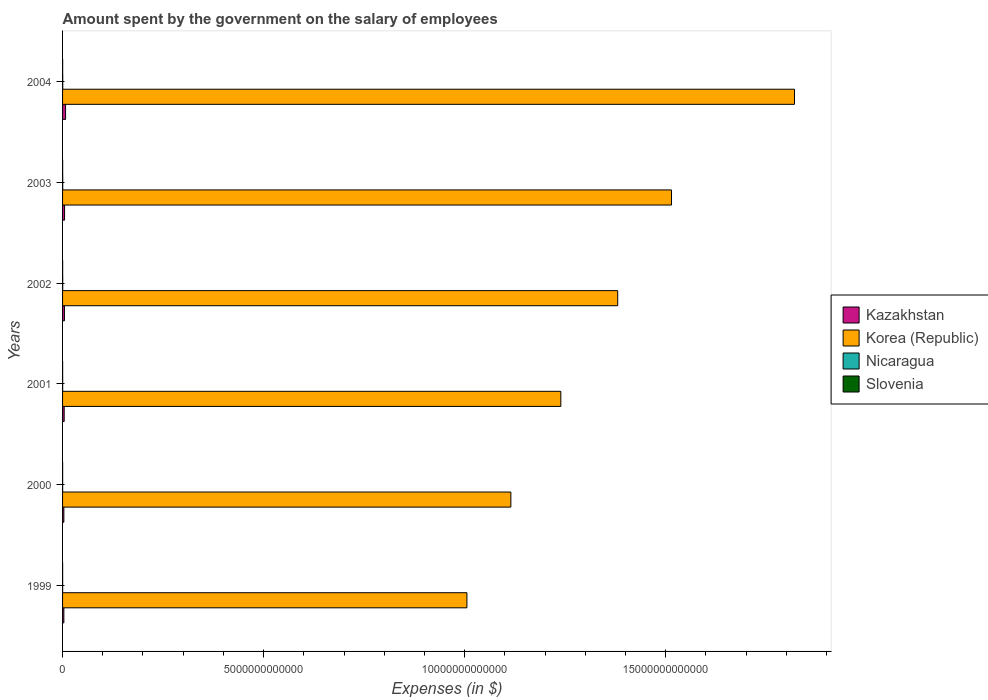How many different coloured bars are there?
Provide a succinct answer. 4. How many groups of bars are there?
Offer a very short reply. 6. Are the number of bars per tick equal to the number of legend labels?
Offer a very short reply. Yes. What is the label of the 1st group of bars from the top?
Offer a terse response. 2004. In how many cases, is the number of bars for a given year not equal to the number of legend labels?
Offer a terse response. 0. What is the amount spent on the salary of employees by the government in Nicaragua in 2001?
Your answer should be very brief. 2.25e+09. Across all years, what is the maximum amount spent on the salary of employees by the government in Slovenia?
Ensure brevity in your answer.  2.02e+09. Across all years, what is the minimum amount spent on the salary of employees by the government in Nicaragua?
Ensure brevity in your answer.  1.68e+09. In which year was the amount spent on the salary of employees by the government in Korea (Republic) minimum?
Offer a very short reply. 1999. What is the total amount spent on the salary of employees by the government in Kazakhstan in the graph?
Give a very brief answer. 2.76e+11. What is the difference between the amount spent on the salary of employees by the government in Nicaragua in 2000 and that in 2002?
Your answer should be compact. -1.56e+09. What is the difference between the amount spent on the salary of employees by the government in Nicaragua in 2000 and the amount spent on the salary of employees by the government in Kazakhstan in 1999?
Your answer should be very brief. -3.05e+1. What is the average amount spent on the salary of employees by the government in Korea (Republic) per year?
Offer a terse response. 1.35e+13. In the year 2003, what is the difference between the amount spent on the salary of employees by the government in Korea (Republic) and amount spent on the salary of employees by the government in Nicaragua?
Provide a succinct answer. 1.51e+13. In how many years, is the amount spent on the salary of employees by the government in Korea (Republic) greater than 7000000000000 $?
Your answer should be very brief. 6. What is the ratio of the amount spent on the salary of employees by the government in Korea (Republic) in 2003 to that in 2004?
Offer a terse response. 0.83. Is the amount spent on the salary of employees by the government in Kazakhstan in 1999 less than that in 2001?
Provide a short and direct response. Yes. What is the difference between the highest and the second highest amount spent on the salary of employees by the government in Kazakhstan?
Keep it short and to the point. 2.48e+1. What is the difference between the highest and the lowest amount spent on the salary of employees by the government in Korea (Republic)?
Keep it short and to the point. 8.15e+12. In how many years, is the amount spent on the salary of employees by the government in Kazakhstan greater than the average amount spent on the salary of employees by the government in Kazakhstan taken over all years?
Offer a very short reply. 3. What does the 2nd bar from the top in 2001 represents?
Make the answer very short. Nicaragua. What does the 3rd bar from the bottom in 2001 represents?
Keep it short and to the point. Nicaragua. Is it the case that in every year, the sum of the amount spent on the salary of employees by the government in Slovenia and amount spent on the salary of employees by the government in Korea (Republic) is greater than the amount spent on the salary of employees by the government in Kazakhstan?
Your answer should be compact. Yes. How many bars are there?
Your answer should be very brief. 24. What is the difference between two consecutive major ticks on the X-axis?
Your answer should be compact. 5.00e+12. Are the values on the major ticks of X-axis written in scientific E-notation?
Ensure brevity in your answer.  No. Does the graph contain grids?
Your answer should be very brief. No. Where does the legend appear in the graph?
Provide a short and direct response. Center right. What is the title of the graph?
Ensure brevity in your answer.  Amount spent by the government on the salary of employees. What is the label or title of the X-axis?
Your answer should be very brief. Expenses (in $). What is the label or title of the Y-axis?
Offer a terse response. Years. What is the Expenses (in $) of Kazakhstan in 1999?
Give a very brief answer. 3.23e+1. What is the Expenses (in $) in Korea (Republic) in 1999?
Your answer should be very brief. 1.01e+13. What is the Expenses (in $) in Nicaragua in 1999?
Your answer should be compact. 1.68e+09. What is the Expenses (in $) of Slovenia in 1999?
Offer a very short reply. 1.34e+09. What is the Expenses (in $) of Kazakhstan in 2000?
Keep it short and to the point. 3.23e+1. What is the Expenses (in $) of Korea (Republic) in 2000?
Provide a short and direct response. 1.12e+13. What is the Expenses (in $) of Nicaragua in 2000?
Make the answer very short. 1.89e+09. What is the Expenses (in $) of Slovenia in 2000?
Ensure brevity in your answer.  1.30e+09. What is the Expenses (in $) in Kazakhstan in 2001?
Your answer should be very brief. 4.00e+1. What is the Expenses (in $) of Korea (Republic) in 2001?
Give a very brief answer. 1.24e+13. What is the Expenses (in $) in Nicaragua in 2001?
Your response must be concise. 2.25e+09. What is the Expenses (in $) in Slovenia in 2001?
Your answer should be very brief. 1.55e+09. What is the Expenses (in $) in Kazakhstan in 2002?
Your answer should be very brief. 4.66e+1. What is the Expenses (in $) in Korea (Republic) in 2002?
Keep it short and to the point. 1.38e+13. What is the Expenses (in $) of Nicaragua in 2002?
Your answer should be very brief. 3.44e+09. What is the Expenses (in $) of Slovenia in 2002?
Your response must be concise. 1.67e+09. What is the Expenses (in $) in Kazakhstan in 2003?
Your answer should be compact. 5.01e+1. What is the Expenses (in $) in Korea (Republic) in 2003?
Make the answer very short. 1.51e+13. What is the Expenses (in $) in Nicaragua in 2003?
Keep it short and to the point. 3.83e+09. What is the Expenses (in $) of Slovenia in 2003?
Offer a terse response. 1.87e+09. What is the Expenses (in $) in Kazakhstan in 2004?
Keep it short and to the point. 7.49e+1. What is the Expenses (in $) in Korea (Republic) in 2004?
Make the answer very short. 1.82e+13. What is the Expenses (in $) of Nicaragua in 2004?
Keep it short and to the point. 4.18e+09. What is the Expenses (in $) in Slovenia in 2004?
Keep it short and to the point. 2.02e+09. Across all years, what is the maximum Expenses (in $) of Kazakhstan?
Keep it short and to the point. 7.49e+1. Across all years, what is the maximum Expenses (in $) of Korea (Republic)?
Your answer should be compact. 1.82e+13. Across all years, what is the maximum Expenses (in $) of Nicaragua?
Keep it short and to the point. 4.18e+09. Across all years, what is the maximum Expenses (in $) of Slovenia?
Your answer should be compact. 2.02e+09. Across all years, what is the minimum Expenses (in $) in Kazakhstan?
Give a very brief answer. 3.23e+1. Across all years, what is the minimum Expenses (in $) of Korea (Republic)?
Make the answer very short. 1.01e+13. Across all years, what is the minimum Expenses (in $) in Nicaragua?
Your answer should be compact. 1.68e+09. Across all years, what is the minimum Expenses (in $) in Slovenia?
Offer a very short reply. 1.30e+09. What is the total Expenses (in $) of Kazakhstan in the graph?
Your answer should be compact. 2.76e+11. What is the total Expenses (in $) in Korea (Republic) in the graph?
Your answer should be compact. 8.08e+13. What is the total Expenses (in $) in Nicaragua in the graph?
Offer a terse response. 1.73e+1. What is the total Expenses (in $) in Slovenia in the graph?
Offer a terse response. 9.75e+09. What is the difference between the Expenses (in $) of Kazakhstan in 1999 and that in 2000?
Give a very brief answer. 2.18e+07. What is the difference between the Expenses (in $) of Korea (Republic) in 1999 and that in 2000?
Provide a succinct answer. -1.09e+12. What is the difference between the Expenses (in $) in Nicaragua in 1999 and that in 2000?
Offer a terse response. -2.03e+08. What is the difference between the Expenses (in $) of Slovenia in 1999 and that in 2000?
Your answer should be compact. 4.36e+07. What is the difference between the Expenses (in $) in Kazakhstan in 1999 and that in 2001?
Give a very brief answer. -7.62e+09. What is the difference between the Expenses (in $) of Korea (Republic) in 1999 and that in 2001?
Offer a terse response. -2.34e+12. What is the difference between the Expenses (in $) in Nicaragua in 1999 and that in 2001?
Provide a succinct answer. -5.69e+08. What is the difference between the Expenses (in $) in Slovenia in 1999 and that in 2001?
Provide a succinct answer. -2.05e+08. What is the difference between the Expenses (in $) in Kazakhstan in 1999 and that in 2002?
Offer a very short reply. -1.42e+1. What is the difference between the Expenses (in $) in Korea (Republic) in 1999 and that in 2002?
Offer a terse response. -3.75e+12. What is the difference between the Expenses (in $) in Nicaragua in 1999 and that in 2002?
Ensure brevity in your answer.  -1.76e+09. What is the difference between the Expenses (in $) in Slovenia in 1999 and that in 2002?
Keep it short and to the point. -3.32e+08. What is the difference between the Expenses (in $) of Kazakhstan in 1999 and that in 2003?
Ensure brevity in your answer.  -1.77e+1. What is the difference between the Expenses (in $) of Korea (Republic) in 1999 and that in 2003?
Provide a succinct answer. -5.09e+12. What is the difference between the Expenses (in $) in Nicaragua in 1999 and that in 2003?
Give a very brief answer. -2.15e+09. What is the difference between the Expenses (in $) of Slovenia in 1999 and that in 2003?
Provide a short and direct response. -5.33e+08. What is the difference between the Expenses (in $) of Kazakhstan in 1999 and that in 2004?
Provide a succinct answer. -4.25e+1. What is the difference between the Expenses (in $) in Korea (Republic) in 1999 and that in 2004?
Your answer should be very brief. -8.15e+12. What is the difference between the Expenses (in $) of Nicaragua in 1999 and that in 2004?
Your response must be concise. -2.50e+09. What is the difference between the Expenses (in $) of Slovenia in 1999 and that in 2004?
Provide a short and direct response. -6.75e+08. What is the difference between the Expenses (in $) of Kazakhstan in 2000 and that in 2001?
Your response must be concise. -7.64e+09. What is the difference between the Expenses (in $) in Korea (Republic) in 2000 and that in 2001?
Offer a very short reply. -1.24e+12. What is the difference between the Expenses (in $) of Nicaragua in 2000 and that in 2001?
Ensure brevity in your answer.  -3.65e+08. What is the difference between the Expenses (in $) of Slovenia in 2000 and that in 2001?
Give a very brief answer. -2.49e+08. What is the difference between the Expenses (in $) of Kazakhstan in 2000 and that in 2002?
Provide a short and direct response. -1.42e+1. What is the difference between the Expenses (in $) in Korea (Republic) in 2000 and that in 2002?
Offer a very short reply. -2.66e+12. What is the difference between the Expenses (in $) in Nicaragua in 2000 and that in 2002?
Your answer should be very brief. -1.56e+09. What is the difference between the Expenses (in $) of Slovenia in 2000 and that in 2002?
Your answer should be compact. -3.76e+08. What is the difference between the Expenses (in $) in Kazakhstan in 2000 and that in 2003?
Keep it short and to the point. -1.77e+1. What is the difference between the Expenses (in $) in Korea (Republic) in 2000 and that in 2003?
Offer a terse response. -4.00e+12. What is the difference between the Expenses (in $) in Nicaragua in 2000 and that in 2003?
Your answer should be compact. -1.95e+09. What is the difference between the Expenses (in $) of Slovenia in 2000 and that in 2003?
Your response must be concise. -5.77e+08. What is the difference between the Expenses (in $) in Kazakhstan in 2000 and that in 2004?
Provide a short and direct response. -4.26e+1. What is the difference between the Expenses (in $) of Korea (Republic) in 2000 and that in 2004?
Offer a very short reply. -7.06e+12. What is the difference between the Expenses (in $) in Nicaragua in 2000 and that in 2004?
Your answer should be compact. -2.29e+09. What is the difference between the Expenses (in $) in Slovenia in 2000 and that in 2004?
Your response must be concise. -7.19e+08. What is the difference between the Expenses (in $) in Kazakhstan in 2001 and that in 2002?
Provide a short and direct response. -6.59e+09. What is the difference between the Expenses (in $) in Korea (Republic) in 2001 and that in 2002?
Keep it short and to the point. -1.41e+12. What is the difference between the Expenses (in $) in Nicaragua in 2001 and that in 2002?
Ensure brevity in your answer.  -1.19e+09. What is the difference between the Expenses (in $) in Slovenia in 2001 and that in 2002?
Your answer should be compact. -1.27e+08. What is the difference between the Expenses (in $) in Kazakhstan in 2001 and that in 2003?
Provide a short and direct response. -1.01e+1. What is the difference between the Expenses (in $) in Korea (Republic) in 2001 and that in 2003?
Offer a terse response. -2.75e+12. What is the difference between the Expenses (in $) of Nicaragua in 2001 and that in 2003?
Give a very brief answer. -1.58e+09. What is the difference between the Expenses (in $) of Slovenia in 2001 and that in 2003?
Make the answer very short. -3.28e+08. What is the difference between the Expenses (in $) in Kazakhstan in 2001 and that in 2004?
Give a very brief answer. -3.49e+1. What is the difference between the Expenses (in $) in Korea (Republic) in 2001 and that in 2004?
Ensure brevity in your answer.  -5.81e+12. What is the difference between the Expenses (in $) in Nicaragua in 2001 and that in 2004?
Ensure brevity in your answer.  -1.93e+09. What is the difference between the Expenses (in $) of Slovenia in 2001 and that in 2004?
Give a very brief answer. -4.70e+08. What is the difference between the Expenses (in $) in Kazakhstan in 2002 and that in 2003?
Your answer should be very brief. -3.51e+09. What is the difference between the Expenses (in $) of Korea (Republic) in 2002 and that in 2003?
Give a very brief answer. -1.34e+12. What is the difference between the Expenses (in $) in Nicaragua in 2002 and that in 2003?
Offer a terse response. -3.91e+08. What is the difference between the Expenses (in $) in Slovenia in 2002 and that in 2003?
Offer a very short reply. -2.01e+08. What is the difference between the Expenses (in $) in Kazakhstan in 2002 and that in 2004?
Your answer should be very brief. -2.83e+1. What is the difference between the Expenses (in $) of Korea (Republic) in 2002 and that in 2004?
Ensure brevity in your answer.  -4.40e+12. What is the difference between the Expenses (in $) in Nicaragua in 2002 and that in 2004?
Your answer should be very brief. -7.34e+08. What is the difference between the Expenses (in $) of Slovenia in 2002 and that in 2004?
Keep it short and to the point. -3.43e+08. What is the difference between the Expenses (in $) of Kazakhstan in 2003 and that in 2004?
Offer a terse response. -2.48e+1. What is the difference between the Expenses (in $) in Korea (Republic) in 2003 and that in 2004?
Provide a short and direct response. -3.06e+12. What is the difference between the Expenses (in $) in Nicaragua in 2003 and that in 2004?
Provide a short and direct response. -3.44e+08. What is the difference between the Expenses (in $) of Slovenia in 2003 and that in 2004?
Your response must be concise. -1.42e+08. What is the difference between the Expenses (in $) of Kazakhstan in 1999 and the Expenses (in $) of Korea (Republic) in 2000?
Keep it short and to the point. -1.11e+13. What is the difference between the Expenses (in $) of Kazakhstan in 1999 and the Expenses (in $) of Nicaragua in 2000?
Provide a succinct answer. 3.05e+1. What is the difference between the Expenses (in $) of Kazakhstan in 1999 and the Expenses (in $) of Slovenia in 2000?
Give a very brief answer. 3.10e+1. What is the difference between the Expenses (in $) in Korea (Republic) in 1999 and the Expenses (in $) in Nicaragua in 2000?
Make the answer very short. 1.01e+13. What is the difference between the Expenses (in $) of Korea (Republic) in 1999 and the Expenses (in $) of Slovenia in 2000?
Your answer should be very brief. 1.01e+13. What is the difference between the Expenses (in $) of Nicaragua in 1999 and the Expenses (in $) of Slovenia in 2000?
Offer a very short reply. 3.85e+08. What is the difference between the Expenses (in $) of Kazakhstan in 1999 and the Expenses (in $) of Korea (Republic) in 2001?
Make the answer very short. -1.24e+13. What is the difference between the Expenses (in $) in Kazakhstan in 1999 and the Expenses (in $) in Nicaragua in 2001?
Give a very brief answer. 3.01e+1. What is the difference between the Expenses (in $) of Kazakhstan in 1999 and the Expenses (in $) of Slovenia in 2001?
Give a very brief answer. 3.08e+1. What is the difference between the Expenses (in $) in Korea (Republic) in 1999 and the Expenses (in $) in Nicaragua in 2001?
Make the answer very short. 1.01e+13. What is the difference between the Expenses (in $) of Korea (Republic) in 1999 and the Expenses (in $) of Slovenia in 2001?
Your response must be concise. 1.01e+13. What is the difference between the Expenses (in $) in Nicaragua in 1999 and the Expenses (in $) in Slovenia in 2001?
Make the answer very short. 1.36e+08. What is the difference between the Expenses (in $) of Kazakhstan in 1999 and the Expenses (in $) of Korea (Republic) in 2002?
Give a very brief answer. -1.38e+13. What is the difference between the Expenses (in $) in Kazakhstan in 1999 and the Expenses (in $) in Nicaragua in 2002?
Provide a succinct answer. 2.89e+1. What is the difference between the Expenses (in $) of Kazakhstan in 1999 and the Expenses (in $) of Slovenia in 2002?
Make the answer very short. 3.07e+1. What is the difference between the Expenses (in $) in Korea (Republic) in 1999 and the Expenses (in $) in Nicaragua in 2002?
Give a very brief answer. 1.01e+13. What is the difference between the Expenses (in $) in Korea (Republic) in 1999 and the Expenses (in $) in Slovenia in 2002?
Keep it short and to the point. 1.01e+13. What is the difference between the Expenses (in $) in Nicaragua in 1999 and the Expenses (in $) in Slovenia in 2002?
Make the answer very short. 9.28e+06. What is the difference between the Expenses (in $) in Kazakhstan in 1999 and the Expenses (in $) in Korea (Republic) in 2003?
Offer a very short reply. -1.51e+13. What is the difference between the Expenses (in $) of Kazakhstan in 1999 and the Expenses (in $) of Nicaragua in 2003?
Your answer should be compact. 2.85e+1. What is the difference between the Expenses (in $) in Kazakhstan in 1999 and the Expenses (in $) in Slovenia in 2003?
Provide a short and direct response. 3.05e+1. What is the difference between the Expenses (in $) in Korea (Republic) in 1999 and the Expenses (in $) in Nicaragua in 2003?
Offer a terse response. 1.01e+13. What is the difference between the Expenses (in $) of Korea (Republic) in 1999 and the Expenses (in $) of Slovenia in 2003?
Provide a short and direct response. 1.01e+13. What is the difference between the Expenses (in $) in Nicaragua in 1999 and the Expenses (in $) in Slovenia in 2003?
Make the answer very short. -1.91e+08. What is the difference between the Expenses (in $) of Kazakhstan in 1999 and the Expenses (in $) of Korea (Republic) in 2004?
Provide a short and direct response. -1.82e+13. What is the difference between the Expenses (in $) of Kazakhstan in 1999 and the Expenses (in $) of Nicaragua in 2004?
Your answer should be compact. 2.82e+1. What is the difference between the Expenses (in $) in Kazakhstan in 1999 and the Expenses (in $) in Slovenia in 2004?
Offer a very short reply. 3.03e+1. What is the difference between the Expenses (in $) of Korea (Republic) in 1999 and the Expenses (in $) of Nicaragua in 2004?
Your answer should be very brief. 1.01e+13. What is the difference between the Expenses (in $) of Korea (Republic) in 1999 and the Expenses (in $) of Slovenia in 2004?
Provide a short and direct response. 1.01e+13. What is the difference between the Expenses (in $) in Nicaragua in 1999 and the Expenses (in $) in Slovenia in 2004?
Offer a very short reply. -3.34e+08. What is the difference between the Expenses (in $) in Kazakhstan in 2000 and the Expenses (in $) in Korea (Republic) in 2001?
Offer a terse response. -1.24e+13. What is the difference between the Expenses (in $) in Kazakhstan in 2000 and the Expenses (in $) in Nicaragua in 2001?
Provide a short and direct response. 3.01e+1. What is the difference between the Expenses (in $) in Kazakhstan in 2000 and the Expenses (in $) in Slovenia in 2001?
Provide a short and direct response. 3.08e+1. What is the difference between the Expenses (in $) in Korea (Republic) in 2000 and the Expenses (in $) in Nicaragua in 2001?
Make the answer very short. 1.11e+13. What is the difference between the Expenses (in $) in Korea (Republic) in 2000 and the Expenses (in $) in Slovenia in 2001?
Your answer should be very brief. 1.11e+13. What is the difference between the Expenses (in $) of Nicaragua in 2000 and the Expenses (in $) of Slovenia in 2001?
Provide a short and direct response. 3.40e+08. What is the difference between the Expenses (in $) in Kazakhstan in 2000 and the Expenses (in $) in Korea (Republic) in 2002?
Provide a succinct answer. -1.38e+13. What is the difference between the Expenses (in $) of Kazakhstan in 2000 and the Expenses (in $) of Nicaragua in 2002?
Keep it short and to the point. 2.89e+1. What is the difference between the Expenses (in $) of Kazakhstan in 2000 and the Expenses (in $) of Slovenia in 2002?
Your response must be concise. 3.06e+1. What is the difference between the Expenses (in $) in Korea (Republic) in 2000 and the Expenses (in $) in Nicaragua in 2002?
Provide a short and direct response. 1.11e+13. What is the difference between the Expenses (in $) in Korea (Republic) in 2000 and the Expenses (in $) in Slovenia in 2002?
Provide a short and direct response. 1.11e+13. What is the difference between the Expenses (in $) of Nicaragua in 2000 and the Expenses (in $) of Slovenia in 2002?
Keep it short and to the point. 2.13e+08. What is the difference between the Expenses (in $) of Kazakhstan in 2000 and the Expenses (in $) of Korea (Republic) in 2003?
Your response must be concise. -1.51e+13. What is the difference between the Expenses (in $) of Kazakhstan in 2000 and the Expenses (in $) of Nicaragua in 2003?
Offer a very short reply. 2.85e+1. What is the difference between the Expenses (in $) of Kazakhstan in 2000 and the Expenses (in $) of Slovenia in 2003?
Offer a very short reply. 3.04e+1. What is the difference between the Expenses (in $) in Korea (Republic) in 2000 and the Expenses (in $) in Nicaragua in 2003?
Offer a very short reply. 1.11e+13. What is the difference between the Expenses (in $) of Korea (Republic) in 2000 and the Expenses (in $) of Slovenia in 2003?
Your answer should be very brief. 1.11e+13. What is the difference between the Expenses (in $) in Nicaragua in 2000 and the Expenses (in $) in Slovenia in 2003?
Provide a short and direct response. 1.20e+07. What is the difference between the Expenses (in $) of Kazakhstan in 2000 and the Expenses (in $) of Korea (Republic) in 2004?
Make the answer very short. -1.82e+13. What is the difference between the Expenses (in $) in Kazakhstan in 2000 and the Expenses (in $) in Nicaragua in 2004?
Make the answer very short. 2.81e+1. What is the difference between the Expenses (in $) of Kazakhstan in 2000 and the Expenses (in $) of Slovenia in 2004?
Give a very brief answer. 3.03e+1. What is the difference between the Expenses (in $) in Korea (Republic) in 2000 and the Expenses (in $) in Nicaragua in 2004?
Offer a very short reply. 1.11e+13. What is the difference between the Expenses (in $) in Korea (Republic) in 2000 and the Expenses (in $) in Slovenia in 2004?
Your response must be concise. 1.11e+13. What is the difference between the Expenses (in $) in Nicaragua in 2000 and the Expenses (in $) in Slovenia in 2004?
Your answer should be compact. -1.30e+08. What is the difference between the Expenses (in $) of Kazakhstan in 2001 and the Expenses (in $) of Korea (Republic) in 2002?
Offer a very short reply. -1.38e+13. What is the difference between the Expenses (in $) of Kazakhstan in 2001 and the Expenses (in $) of Nicaragua in 2002?
Keep it short and to the point. 3.65e+1. What is the difference between the Expenses (in $) in Kazakhstan in 2001 and the Expenses (in $) in Slovenia in 2002?
Your answer should be compact. 3.83e+1. What is the difference between the Expenses (in $) of Korea (Republic) in 2001 and the Expenses (in $) of Nicaragua in 2002?
Keep it short and to the point. 1.24e+13. What is the difference between the Expenses (in $) in Korea (Republic) in 2001 and the Expenses (in $) in Slovenia in 2002?
Make the answer very short. 1.24e+13. What is the difference between the Expenses (in $) in Nicaragua in 2001 and the Expenses (in $) in Slovenia in 2002?
Your answer should be compact. 5.78e+08. What is the difference between the Expenses (in $) of Kazakhstan in 2001 and the Expenses (in $) of Korea (Republic) in 2003?
Provide a short and direct response. -1.51e+13. What is the difference between the Expenses (in $) in Kazakhstan in 2001 and the Expenses (in $) in Nicaragua in 2003?
Make the answer very short. 3.61e+1. What is the difference between the Expenses (in $) of Kazakhstan in 2001 and the Expenses (in $) of Slovenia in 2003?
Your answer should be compact. 3.81e+1. What is the difference between the Expenses (in $) of Korea (Republic) in 2001 and the Expenses (in $) of Nicaragua in 2003?
Your response must be concise. 1.24e+13. What is the difference between the Expenses (in $) of Korea (Republic) in 2001 and the Expenses (in $) of Slovenia in 2003?
Keep it short and to the point. 1.24e+13. What is the difference between the Expenses (in $) of Nicaragua in 2001 and the Expenses (in $) of Slovenia in 2003?
Offer a very short reply. 3.77e+08. What is the difference between the Expenses (in $) of Kazakhstan in 2001 and the Expenses (in $) of Korea (Republic) in 2004?
Your answer should be very brief. -1.82e+13. What is the difference between the Expenses (in $) of Kazakhstan in 2001 and the Expenses (in $) of Nicaragua in 2004?
Your response must be concise. 3.58e+1. What is the difference between the Expenses (in $) in Kazakhstan in 2001 and the Expenses (in $) in Slovenia in 2004?
Offer a terse response. 3.79e+1. What is the difference between the Expenses (in $) of Korea (Republic) in 2001 and the Expenses (in $) of Nicaragua in 2004?
Ensure brevity in your answer.  1.24e+13. What is the difference between the Expenses (in $) in Korea (Republic) in 2001 and the Expenses (in $) in Slovenia in 2004?
Keep it short and to the point. 1.24e+13. What is the difference between the Expenses (in $) of Nicaragua in 2001 and the Expenses (in $) of Slovenia in 2004?
Ensure brevity in your answer.  2.35e+08. What is the difference between the Expenses (in $) in Kazakhstan in 2002 and the Expenses (in $) in Korea (Republic) in 2003?
Provide a succinct answer. -1.51e+13. What is the difference between the Expenses (in $) of Kazakhstan in 2002 and the Expenses (in $) of Nicaragua in 2003?
Keep it short and to the point. 4.27e+1. What is the difference between the Expenses (in $) of Kazakhstan in 2002 and the Expenses (in $) of Slovenia in 2003?
Provide a short and direct response. 4.47e+1. What is the difference between the Expenses (in $) of Korea (Republic) in 2002 and the Expenses (in $) of Nicaragua in 2003?
Provide a succinct answer. 1.38e+13. What is the difference between the Expenses (in $) of Korea (Republic) in 2002 and the Expenses (in $) of Slovenia in 2003?
Make the answer very short. 1.38e+13. What is the difference between the Expenses (in $) in Nicaragua in 2002 and the Expenses (in $) in Slovenia in 2003?
Make the answer very short. 1.57e+09. What is the difference between the Expenses (in $) of Kazakhstan in 2002 and the Expenses (in $) of Korea (Republic) in 2004?
Make the answer very short. -1.82e+13. What is the difference between the Expenses (in $) of Kazakhstan in 2002 and the Expenses (in $) of Nicaragua in 2004?
Ensure brevity in your answer.  4.24e+1. What is the difference between the Expenses (in $) in Kazakhstan in 2002 and the Expenses (in $) in Slovenia in 2004?
Make the answer very short. 4.45e+1. What is the difference between the Expenses (in $) of Korea (Republic) in 2002 and the Expenses (in $) of Nicaragua in 2004?
Provide a succinct answer. 1.38e+13. What is the difference between the Expenses (in $) in Korea (Republic) in 2002 and the Expenses (in $) in Slovenia in 2004?
Ensure brevity in your answer.  1.38e+13. What is the difference between the Expenses (in $) of Nicaragua in 2002 and the Expenses (in $) of Slovenia in 2004?
Provide a succinct answer. 1.43e+09. What is the difference between the Expenses (in $) of Kazakhstan in 2003 and the Expenses (in $) of Korea (Republic) in 2004?
Your answer should be compact. -1.82e+13. What is the difference between the Expenses (in $) of Kazakhstan in 2003 and the Expenses (in $) of Nicaragua in 2004?
Your answer should be compact. 4.59e+1. What is the difference between the Expenses (in $) of Kazakhstan in 2003 and the Expenses (in $) of Slovenia in 2004?
Your response must be concise. 4.80e+1. What is the difference between the Expenses (in $) of Korea (Republic) in 2003 and the Expenses (in $) of Nicaragua in 2004?
Provide a short and direct response. 1.51e+13. What is the difference between the Expenses (in $) in Korea (Republic) in 2003 and the Expenses (in $) in Slovenia in 2004?
Provide a short and direct response. 1.51e+13. What is the difference between the Expenses (in $) in Nicaragua in 2003 and the Expenses (in $) in Slovenia in 2004?
Your answer should be very brief. 1.82e+09. What is the average Expenses (in $) in Kazakhstan per year?
Ensure brevity in your answer.  4.60e+1. What is the average Expenses (in $) in Korea (Republic) per year?
Provide a short and direct response. 1.35e+13. What is the average Expenses (in $) in Nicaragua per year?
Ensure brevity in your answer.  2.88e+09. What is the average Expenses (in $) in Slovenia per year?
Make the answer very short. 1.62e+09. In the year 1999, what is the difference between the Expenses (in $) in Kazakhstan and Expenses (in $) in Korea (Republic)?
Offer a very short reply. -1.00e+13. In the year 1999, what is the difference between the Expenses (in $) in Kazakhstan and Expenses (in $) in Nicaragua?
Provide a short and direct response. 3.07e+1. In the year 1999, what is the difference between the Expenses (in $) in Kazakhstan and Expenses (in $) in Slovenia?
Your answer should be very brief. 3.10e+1. In the year 1999, what is the difference between the Expenses (in $) of Korea (Republic) and Expenses (in $) of Nicaragua?
Provide a succinct answer. 1.01e+13. In the year 1999, what is the difference between the Expenses (in $) in Korea (Republic) and Expenses (in $) in Slovenia?
Your response must be concise. 1.01e+13. In the year 1999, what is the difference between the Expenses (in $) in Nicaragua and Expenses (in $) in Slovenia?
Keep it short and to the point. 3.42e+08. In the year 2000, what is the difference between the Expenses (in $) in Kazakhstan and Expenses (in $) in Korea (Republic)?
Offer a very short reply. -1.11e+13. In the year 2000, what is the difference between the Expenses (in $) of Kazakhstan and Expenses (in $) of Nicaragua?
Give a very brief answer. 3.04e+1. In the year 2000, what is the difference between the Expenses (in $) of Kazakhstan and Expenses (in $) of Slovenia?
Give a very brief answer. 3.10e+1. In the year 2000, what is the difference between the Expenses (in $) in Korea (Republic) and Expenses (in $) in Nicaragua?
Provide a succinct answer. 1.11e+13. In the year 2000, what is the difference between the Expenses (in $) of Korea (Republic) and Expenses (in $) of Slovenia?
Ensure brevity in your answer.  1.11e+13. In the year 2000, what is the difference between the Expenses (in $) in Nicaragua and Expenses (in $) in Slovenia?
Provide a short and direct response. 5.89e+08. In the year 2001, what is the difference between the Expenses (in $) of Kazakhstan and Expenses (in $) of Korea (Republic)?
Keep it short and to the point. -1.24e+13. In the year 2001, what is the difference between the Expenses (in $) of Kazakhstan and Expenses (in $) of Nicaragua?
Offer a very short reply. 3.77e+1. In the year 2001, what is the difference between the Expenses (in $) of Kazakhstan and Expenses (in $) of Slovenia?
Offer a very short reply. 3.84e+1. In the year 2001, what is the difference between the Expenses (in $) of Korea (Republic) and Expenses (in $) of Nicaragua?
Ensure brevity in your answer.  1.24e+13. In the year 2001, what is the difference between the Expenses (in $) of Korea (Republic) and Expenses (in $) of Slovenia?
Offer a terse response. 1.24e+13. In the year 2001, what is the difference between the Expenses (in $) in Nicaragua and Expenses (in $) in Slovenia?
Offer a very short reply. 7.05e+08. In the year 2002, what is the difference between the Expenses (in $) in Kazakhstan and Expenses (in $) in Korea (Republic)?
Make the answer very short. -1.38e+13. In the year 2002, what is the difference between the Expenses (in $) in Kazakhstan and Expenses (in $) in Nicaragua?
Make the answer very short. 4.31e+1. In the year 2002, what is the difference between the Expenses (in $) of Kazakhstan and Expenses (in $) of Slovenia?
Your answer should be compact. 4.49e+1. In the year 2002, what is the difference between the Expenses (in $) of Korea (Republic) and Expenses (in $) of Nicaragua?
Offer a very short reply. 1.38e+13. In the year 2002, what is the difference between the Expenses (in $) of Korea (Republic) and Expenses (in $) of Slovenia?
Provide a succinct answer. 1.38e+13. In the year 2002, what is the difference between the Expenses (in $) in Nicaragua and Expenses (in $) in Slovenia?
Your response must be concise. 1.77e+09. In the year 2003, what is the difference between the Expenses (in $) in Kazakhstan and Expenses (in $) in Korea (Republic)?
Your answer should be compact. -1.51e+13. In the year 2003, what is the difference between the Expenses (in $) of Kazakhstan and Expenses (in $) of Nicaragua?
Make the answer very short. 4.62e+1. In the year 2003, what is the difference between the Expenses (in $) of Kazakhstan and Expenses (in $) of Slovenia?
Provide a succinct answer. 4.82e+1. In the year 2003, what is the difference between the Expenses (in $) of Korea (Republic) and Expenses (in $) of Nicaragua?
Keep it short and to the point. 1.51e+13. In the year 2003, what is the difference between the Expenses (in $) in Korea (Republic) and Expenses (in $) in Slovenia?
Give a very brief answer. 1.51e+13. In the year 2003, what is the difference between the Expenses (in $) of Nicaragua and Expenses (in $) of Slovenia?
Provide a succinct answer. 1.96e+09. In the year 2004, what is the difference between the Expenses (in $) in Kazakhstan and Expenses (in $) in Korea (Republic)?
Your response must be concise. -1.81e+13. In the year 2004, what is the difference between the Expenses (in $) in Kazakhstan and Expenses (in $) in Nicaragua?
Give a very brief answer. 7.07e+1. In the year 2004, what is the difference between the Expenses (in $) of Kazakhstan and Expenses (in $) of Slovenia?
Your answer should be very brief. 7.29e+1. In the year 2004, what is the difference between the Expenses (in $) in Korea (Republic) and Expenses (in $) in Nicaragua?
Your response must be concise. 1.82e+13. In the year 2004, what is the difference between the Expenses (in $) of Korea (Republic) and Expenses (in $) of Slovenia?
Keep it short and to the point. 1.82e+13. In the year 2004, what is the difference between the Expenses (in $) of Nicaragua and Expenses (in $) of Slovenia?
Your answer should be very brief. 2.16e+09. What is the ratio of the Expenses (in $) of Korea (Republic) in 1999 to that in 2000?
Provide a succinct answer. 0.9. What is the ratio of the Expenses (in $) of Nicaragua in 1999 to that in 2000?
Ensure brevity in your answer.  0.89. What is the ratio of the Expenses (in $) in Slovenia in 1999 to that in 2000?
Offer a very short reply. 1.03. What is the ratio of the Expenses (in $) of Kazakhstan in 1999 to that in 2001?
Your answer should be compact. 0.81. What is the ratio of the Expenses (in $) of Korea (Republic) in 1999 to that in 2001?
Provide a short and direct response. 0.81. What is the ratio of the Expenses (in $) in Nicaragua in 1999 to that in 2001?
Your response must be concise. 0.75. What is the ratio of the Expenses (in $) in Slovenia in 1999 to that in 2001?
Your answer should be compact. 0.87. What is the ratio of the Expenses (in $) in Kazakhstan in 1999 to that in 2002?
Make the answer very short. 0.69. What is the ratio of the Expenses (in $) in Korea (Republic) in 1999 to that in 2002?
Offer a very short reply. 0.73. What is the ratio of the Expenses (in $) in Nicaragua in 1999 to that in 2002?
Your response must be concise. 0.49. What is the ratio of the Expenses (in $) in Slovenia in 1999 to that in 2002?
Your answer should be compact. 0.8. What is the ratio of the Expenses (in $) in Kazakhstan in 1999 to that in 2003?
Provide a short and direct response. 0.65. What is the ratio of the Expenses (in $) of Korea (Republic) in 1999 to that in 2003?
Your answer should be compact. 0.66. What is the ratio of the Expenses (in $) of Nicaragua in 1999 to that in 2003?
Make the answer very short. 0.44. What is the ratio of the Expenses (in $) of Slovenia in 1999 to that in 2003?
Your response must be concise. 0.72. What is the ratio of the Expenses (in $) in Kazakhstan in 1999 to that in 2004?
Make the answer very short. 0.43. What is the ratio of the Expenses (in $) of Korea (Republic) in 1999 to that in 2004?
Provide a succinct answer. 0.55. What is the ratio of the Expenses (in $) in Nicaragua in 1999 to that in 2004?
Keep it short and to the point. 0.4. What is the ratio of the Expenses (in $) of Slovenia in 1999 to that in 2004?
Your answer should be very brief. 0.67. What is the ratio of the Expenses (in $) of Kazakhstan in 2000 to that in 2001?
Your answer should be very brief. 0.81. What is the ratio of the Expenses (in $) of Korea (Republic) in 2000 to that in 2001?
Your answer should be very brief. 0.9. What is the ratio of the Expenses (in $) of Nicaragua in 2000 to that in 2001?
Offer a very short reply. 0.84. What is the ratio of the Expenses (in $) of Slovenia in 2000 to that in 2001?
Offer a very short reply. 0.84. What is the ratio of the Expenses (in $) in Kazakhstan in 2000 to that in 2002?
Ensure brevity in your answer.  0.69. What is the ratio of the Expenses (in $) in Korea (Republic) in 2000 to that in 2002?
Your answer should be very brief. 0.81. What is the ratio of the Expenses (in $) in Nicaragua in 2000 to that in 2002?
Make the answer very short. 0.55. What is the ratio of the Expenses (in $) of Slovenia in 2000 to that in 2002?
Offer a very short reply. 0.78. What is the ratio of the Expenses (in $) of Kazakhstan in 2000 to that in 2003?
Provide a succinct answer. 0.65. What is the ratio of the Expenses (in $) in Korea (Republic) in 2000 to that in 2003?
Provide a succinct answer. 0.74. What is the ratio of the Expenses (in $) of Nicaragua in 2000 to that in 2003?
Give a very brief answer. 0.49. What is the ratio of the Expenses (in $) in Slovenia in 2000 to that in 2003?
Ensure brevity in your answer.  0.69. What is the ratio of the Expenses (in $) of Kazakhstan in 2000 to that in 2004?
Offer a very short reply. 0.43. What is the ratio of the Expenses (in $) of Korea (Republic) in 2000 to that in 2004?
Your answer should be very brief. 0.61. What is the ratio of the Expenses (in $) in Nicaragua in 2000 to that in 2004?
Offer a terse response. 0.45. What is the ratio of the Expenses (in $) of Slovenia in 2000 to that in 2004?
Offer a very short reply. 0.64. What is the ratio of the Expenses (in $) in Kazakhstan in 2001 to that in 2002?
Make the answer very short. 0.86. What is the ratio of the Expenses (in $) in Korea (Republic) in 2001 to that in 2002?
Offer a terse response. 0.9. What is the ratio of the Expenses (in $) in Nicaragua in 2001 to that in 2002?
Offer a terse response. 0.65. What is the ratio of the Expenses (in $) in Slovenia in 2001 to that in 2002?
Give a very brief answer. 0.92. What is the ratio of the Expenses (in $) in Kazakhstan in 2001 to that in 2003?
Your answer should be compact. 0.8. What is the ratio of the Expenses (in $) in Korea (Republic) in 2001 to that in 2003?
Provide a succinct answer. 0.82. What is the ratio of the Expenses (in $) in Nicaragua in 2001 to that in 2003?
Offer a terse response. 0.59. What is the ratio of the Expenses (in $) in Slovenia in 2001 to that in 2003?
Your answer should be compact. 0.83. What is the ratio of the Expenses (in $) in Kazakhstan in 2001 to that in 2004?
Provide a short and direct response. 0.53. What is the ratio of the Expenses (in $) in Korea (Republic) in 2001 to that in 2004?
Offer a terse response. 0.68. What is the ratio of the Expenses (in $) in Nicaragua in 2001 to that in 2004?
Offer a very short reply. 0.54. What is the ratio of the Expenses (in $) in Slovenia in 2001 to that in 2004?
Your answer should be very brief. 0.77. What is the ratio of the Expenses (in $) of Kazakhstan in 2002 to that in 2003?
Give a very brief answer. 0.93. What is the ratio of the Expenses (in $) of Korea (Republic) in 2002 to that in 2003?
Make the answer very short. 0.91. What is the ratio of the Expenses (in $) in Nicaragua in 2002 to that in 2003?
Offer a very short reply. 0.9. What is the ratio of the Expenses (in $) in Slovenia in 2002 to that in 2003?
Your answer should be compact. 0.89. What is the ratio of the Expenses (in $) of Kazakhstan in 2002 to that in 2004?
Give a very brief answer. 0.62. What is the ratio of the Expenses (in $) of Korea (Republic) in 2002 to that in 2004?
Make the answer very short. 0.76. What is the ratio of the Expenses (in $) of Nicaragua in 2002 to that in 2004?
Provide a succinct answer. 0.82. What is the ratio of the Expenses (in $) of Slovenia in 2002 to that in 2004?
Give a very brief answer. 0.83. What is the ratio of the Expenses (in $) in Kazakhstan in 2003 to that in 2004?
Your answer should be compact. 0.67. What is the ratio of the Expenses (in $) in Korea (Republic) in 2003 to that in 2004?
Keep it short and to the point. 0.83. What is the ratio of the Expenses (in $) of Nicaragua in 2003 to that in 2004?
Ensure brevity in your answer.  0.92. What is the ratio of the Expenses (in $) of Slovenia in 2003 to that in 2004?
Your answer should be compact. 0.93. What is the difference between the highest and the second highest Expenses (in $) of Kazakhstan?
Ensure brevity in your answer.  2.48e+1. What is the difference between the highest and the second highest Expenses (in $) in Korea (Republic)?
Ensure brevity in your answer.  3.06e+12. What is the difference between the highest and the second highest Expenses (in $) of Nicaragua?
Ensure brevity in your answer.  3.44e+08. What is the difference between the highest and the second highest Expenses (in $) of Slovenia?
Your answer should be very brief. 1.42e+08. What is the difference between the highest and the lowest Expenses (in $) of Kazakhstan?
Offer a very short reply. 4.26e+1. What is the difference between the highest and the lowest Expenses (in $) in Korea (Republic)?
Provide a short and direct response. 8.15e+12. What is the difference between the highest and the lowest Expenses (in $) of Nicaragua?
Provide a short and direct response. 2.50e+09. What is the difference between the highest and the lowest Expenses (in $) of Slovenia?
Your response must be concise. 7.19e+08. 